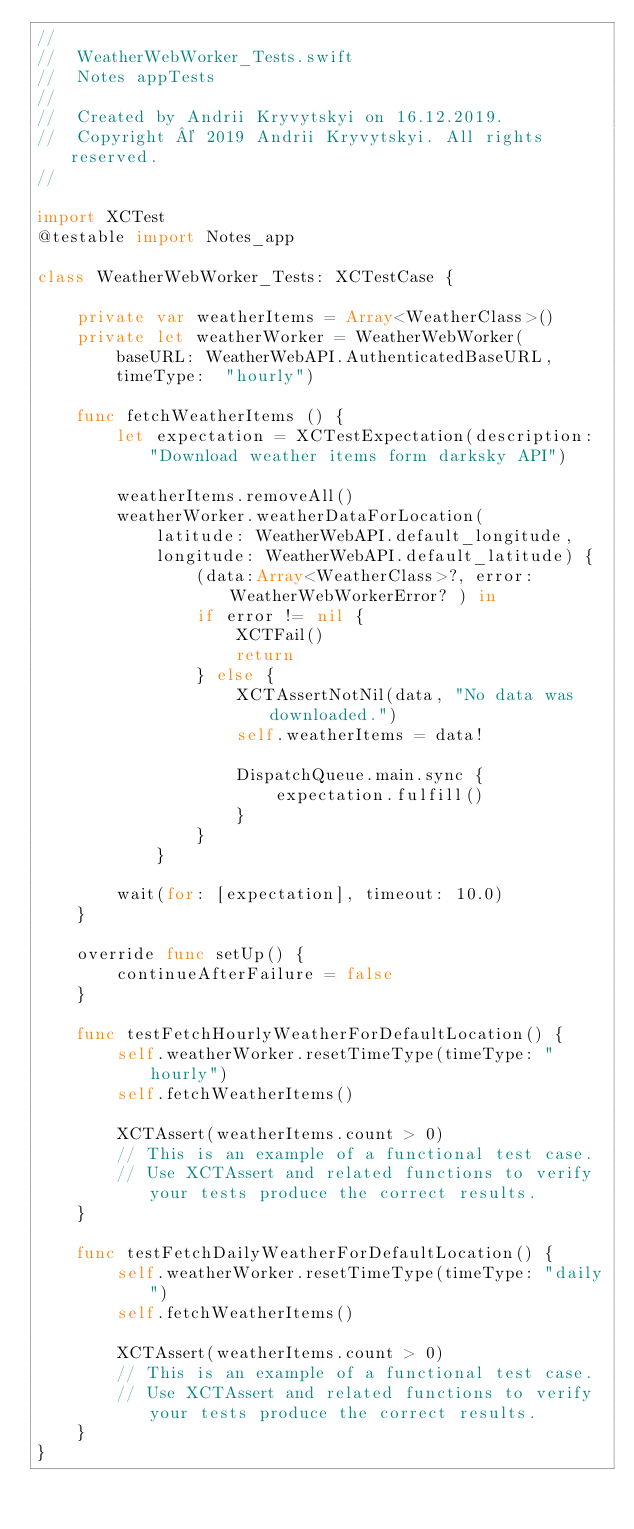Convert code to text. <code><loc_0><loc_0><loc_500><loc_500><_Swift_>//
//  WeatherWebWorker_Tests.swift
//  Notes appTests
//
//  Created by Andrii Kryvytskyi on 16.12.2019.
//  Copyright © 2019 Andrii Kryvytskyi. All rights reserved.
//

import XCTest
@testable import Notes_app

class WeatherWebWorker_Tests: XCTestCase {
    
    private var weatherItems = Array<WeatherClass>()
    private let weatherWorker = WeatherWebWorker(
        baseURL: WeatherWebAPI.AuthenticatedBaseURL,
        timeType:  "hourly")
    
    func fetchWeatherItems () {
        let expectation = XCTestExpectation(description: "Download weather items form darksky API")
        
        weatherItems.removeAll()
        weatherWorker.weatherDataForLocation(
            latitude: WeatherWebAPI.default_longitude,
            longitude: WeatherWebAPI.default_latitude) {
                (data:Array<WeatherClass>?, error:WeatherWebWorkerError? ) in
                if error != nil {
                    XCTFail()
                    return
                } else {
                    XCTAssertNotNil(data, "No data was downloaded.")
                    self.weatherItems = data!
                        
                    DispatchQueue.main.sync {
                        expectation.fulfill()
                    }
                }
            }
        
        wait(for: [expectation], timeout: 10.0)
    }

    override func setUp() {
        continueAfterFailure = false
    }

    func testFetchHourlyWeatherForDefaultLocation() {
        self.weatherWorker.resetTimeType(timeType: "hourly")
        self.fetchWeatherItems()
        
        XCTAssert(weatherItems.count > 0)
        // This is an example of a functional test case.
        // Use XCTAssert and related functions to verify your tests produce the correct results.
    }
    
    func testFetchDailyWeatherForDefaultLocation() {
        self.weatherWorker.resetTimeType(timeType: "daily")
        self.fetchWeatherItems()
        
        XCTAssert(weatherItems.count > 0)
        // This is an example of a functional test case.
        // Use XCTAssert and related functions to verify your tests produce the correct results.
    }
}
</code> 